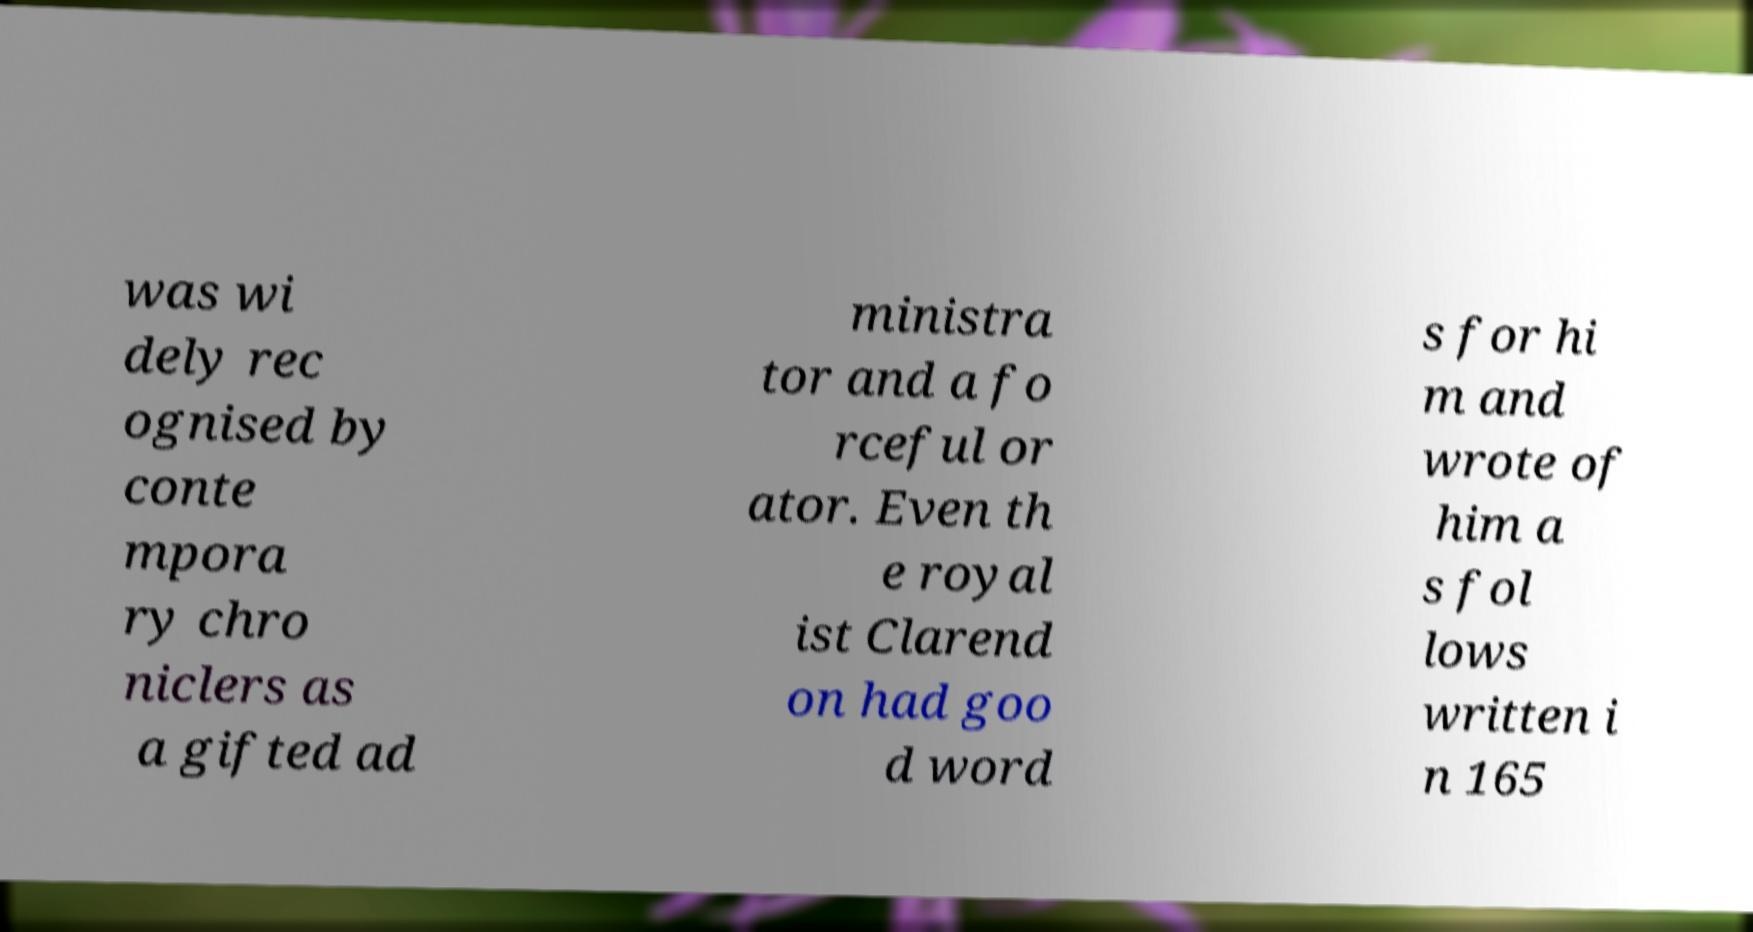For documentation purposes, I need the text within this image transcribed. Could you provide that? was wi dely rec ognised by conte mpora ry chro niclers as a gifted ad ministra tor and a fo rceful or ator. Even th e royal ist Clarend on had goo d word s for hi m and wrote of him a s fol lows written i n 165 